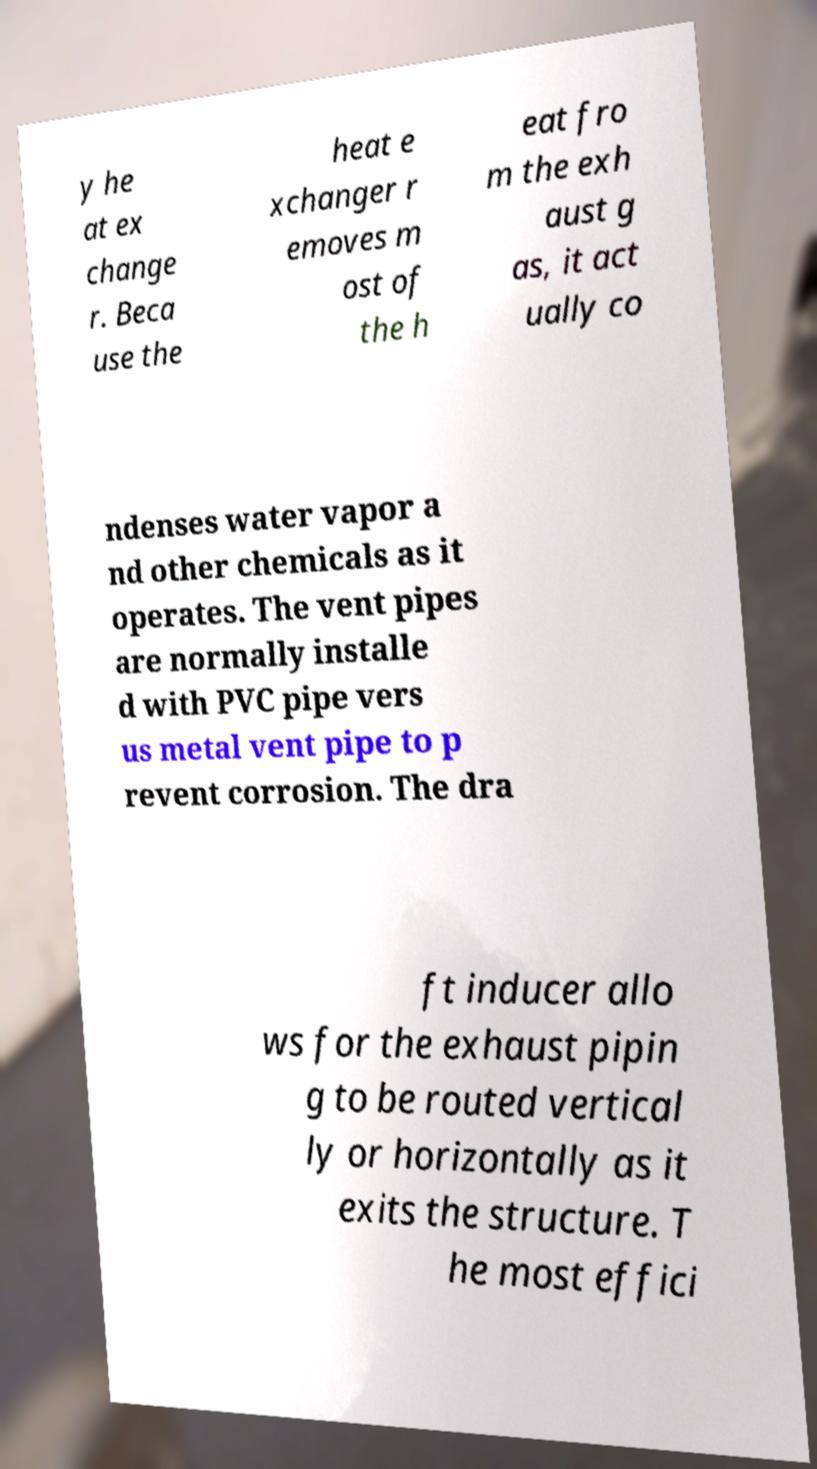Could you assist in decoding the text presented in this image and type it out clearly? y he at ex change r. Beca use the heat e xchanger r emoves m ost of the h eat fro m the exh aust g as, it act ually co ndenses water vapor a nd other chemicals as it operates. The vent pipes are normally installe d with PVC pipe vers us metal vent pipe to p revent corrosion. The dra ft inducer allo ws for the exhaust pipin g to be routed vertical ly or horizontally as it exits the structure. T he most effici 